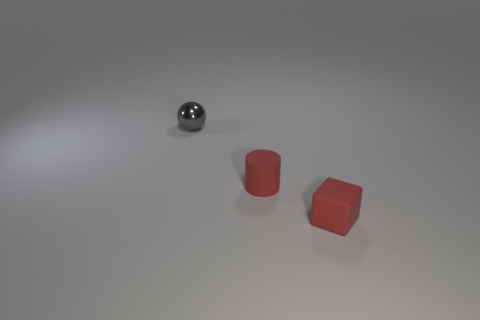What is the color of the small thing behind the tiny red matte thing that is behind the block?
Your answer should be compact. Gray. Is there a matte thing that has the same color as the rubber cylinder?
Your response must be concise. Yes. There is a red thing that is behind the small red thing that is in front of the small red thing left of the small red cube; what is its size?
Your response must be concise. Small. Is the shape of the small metal thing the same as the red object left of the red matte cube?
Provide a succinct answer. No. How many other objects are the same size as the red cube?
Offer a terse response. 2. There is a red rubber thing that is behind the red block; what is its size?
Give a very brief answer. Small. How many small red cylinders have the same material as the tiny cube?
Your answer should be compact. 1. There is a small red thing behind the block; is its shape the same as the tiny gray shiny thing?
Offer a very short reply. No. The red thing that is behind the tiny red cube has what shape?
Keep it short and to the point. Cylinder. What is the size of the cylinder that is the same color as the matte cube?
Give a very brief answer. Small. 